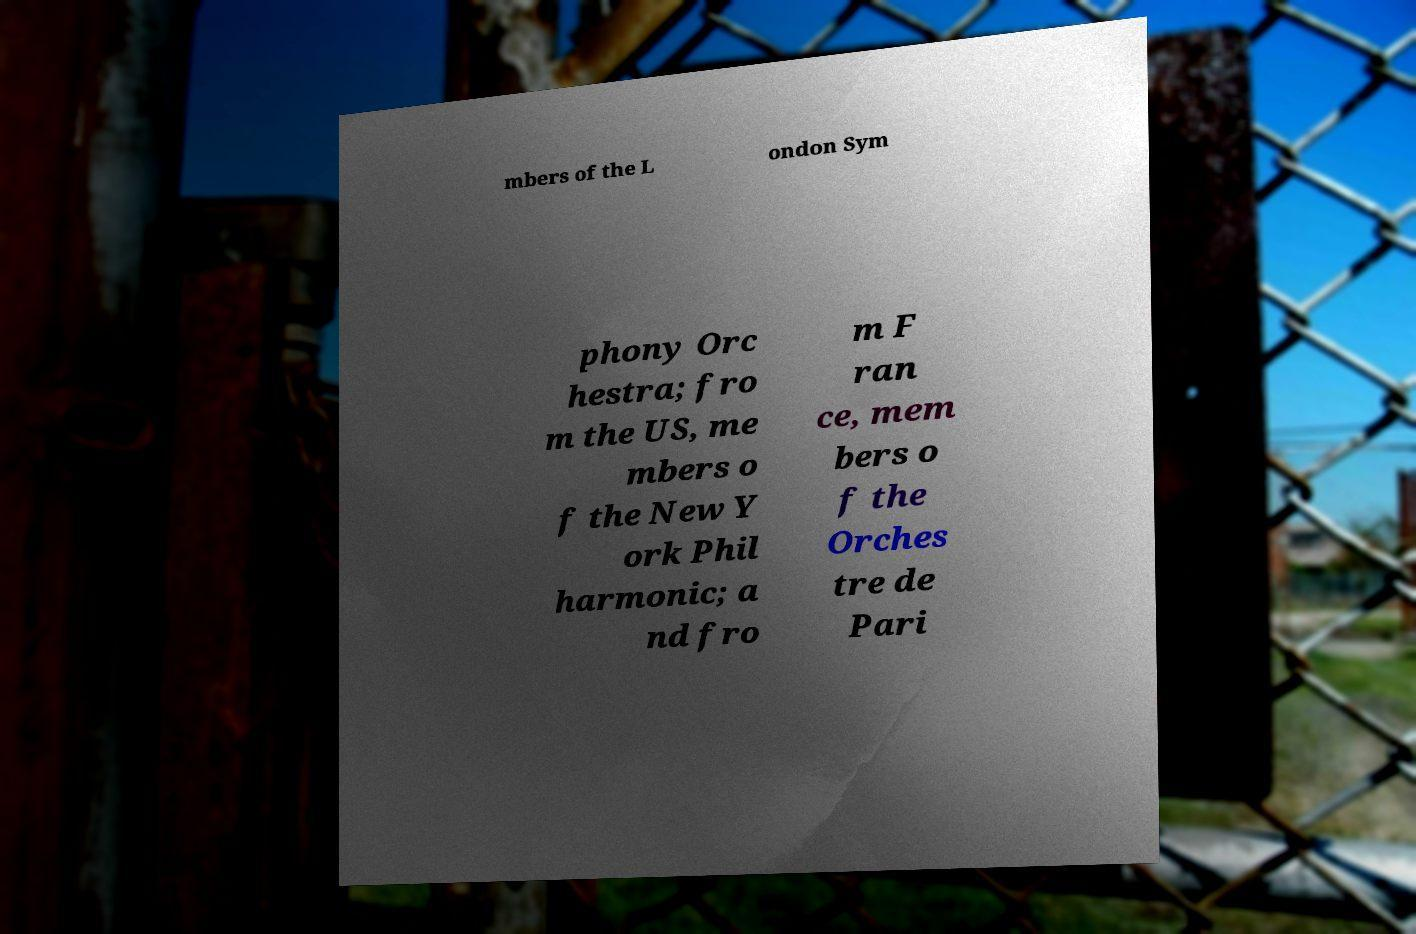For documentation purposes, I need the text within this image transcribed. Could you provide that? mbers of the L ondon Sym phony Orc hestra; fro m the US, me mbers o f the New Y ork Phil harmonic; a nd fro m F ran ce, mem bers o f the Orches tre de Pari 